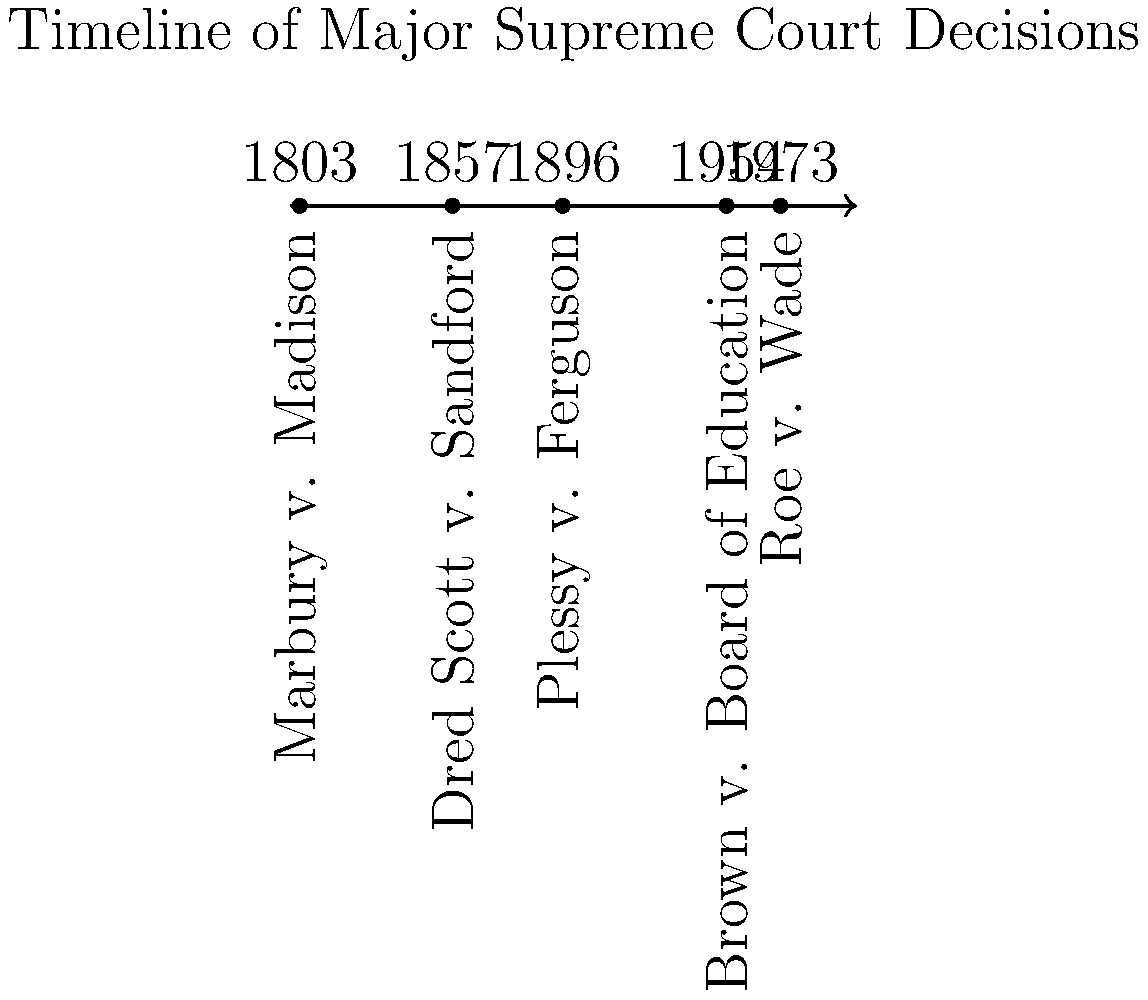Based on the timeline provided, which Supreme Court case established the principle of judicial review and occurred earliest among the cases shown? To answer this question, we need to follow these steps:

1. Understand the concept of judicial review: It's the power of the courts to review and potentially invalidate laws and government actions that violate the Constitution.

2. Examine the timeline:
   - 1803: Marbury v. Madison
   - 1857: Dred Scott v. Sandford
   - 1896: Plessy v. Ferguson
   - 1954: Brown v. Board of Education
   - 1973: Roe v. Wade

3. Identify the earliest case: Marbury v. Madison (1803) is the earliest case on the timeline.

4. Recall the significance of Marbury v. Madison: This landmark case established the principle of judicial review in the United States. Chief Justice John Marshall's opinion asserted the Supreme Court's authority to review the constitutionality of laws and executive actions.

5. Verify that no other case on the timeline is known for establishing judicial review.

Therefore, Marbury v. Madison in 1803 is the correct answer, as it both established judicial review and occurred earliest among the cases shown.
Answer: Marbury v. Madison (1803) 